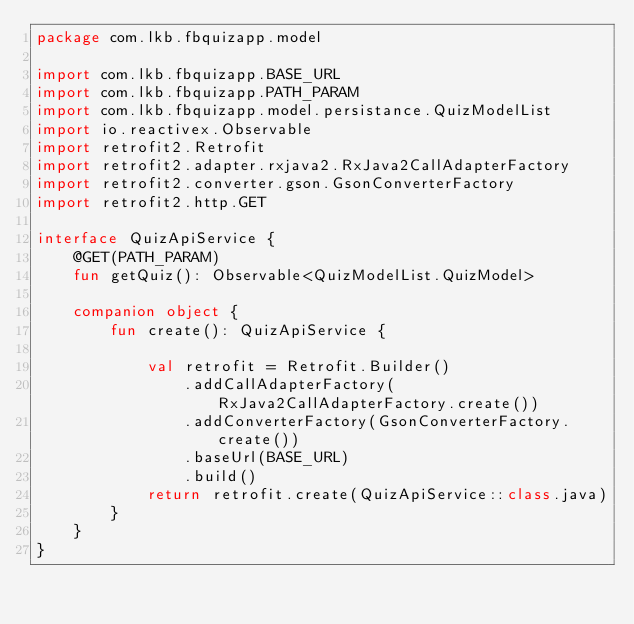Convert code to text. <code><loc_0><loc_0><loc_500><loc_500><_Kotlin_>package com.lkb.fbquizapp.model

import com.lkb.fbquizapp.BASE_URL
import com.lkb.fbquizapp.PATH_PARAM
import com.lkb.fbquizapp.model.persistance.QuizModelList
import io.reactivex.Observable
import retrofit2.Retrofit
import retrofit2.adapter.rxjava2.RxJava2CallAdapterFactory
import retrofit2.converter.gson.GsonConverterFactory
import retrofit2.http.GET

interface QuizApiService {
    @GET(PATH_PARAM)
    fun getQuiz(): Observable<QuizModelList.QuizModel>

    companion object {
        fun create(): QuizApiService {

            val retrofit = Retrofit.Builder()
                .addCallAdapterFactory(RxJava2CallAdapterFactory.create())
                .addConverterFactory(GsonConverterFactory.create())
                .baseUrl(BASE_URL)
                .build()
            return retrofit.create(QuizApiService::class.java)
        }
    }
}</code> 